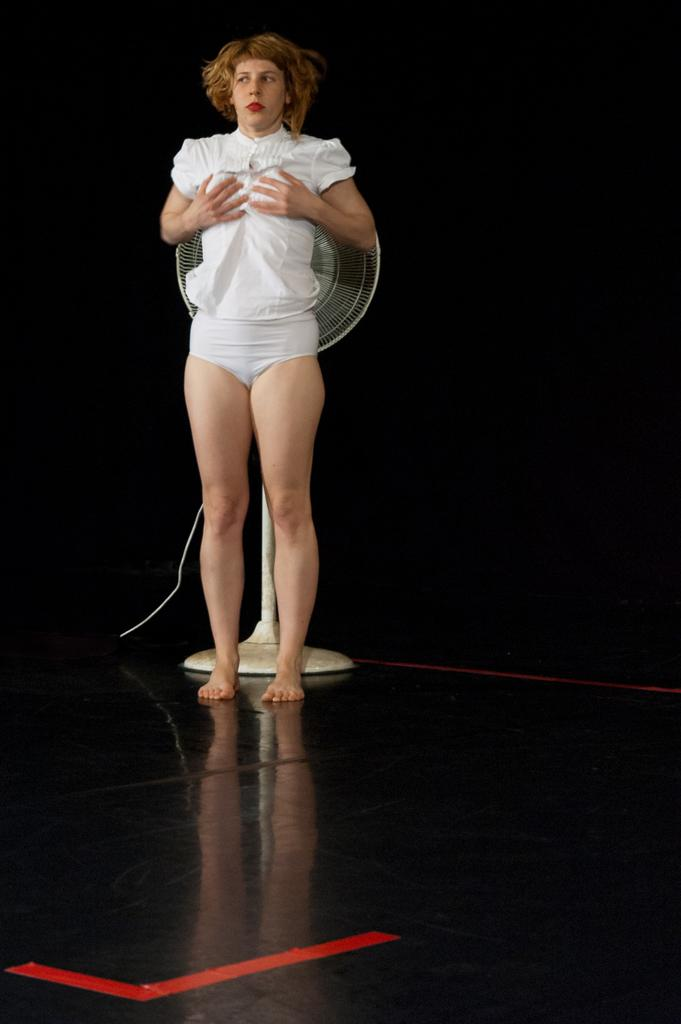What is the main subject of the image? The main subject of the image is a woman standing. What object can be seen on the floor in the image? There is a table fan on the floor in the image. How would you describe the background of the image? The background of the image is dark. How many snails can be seen climbing the hill in the image? There are no snails or hills present in the image. 